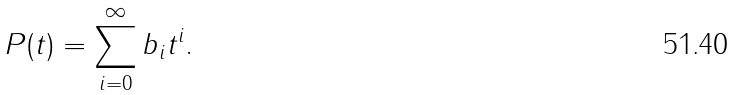Convert formula to latex. <formula><loc_0><loc_0><loc_500><loc_500>P ( t ) = \sum _ { i = 0 } ^ { \infty } b _ { i } t ^ { i } .</formula> 